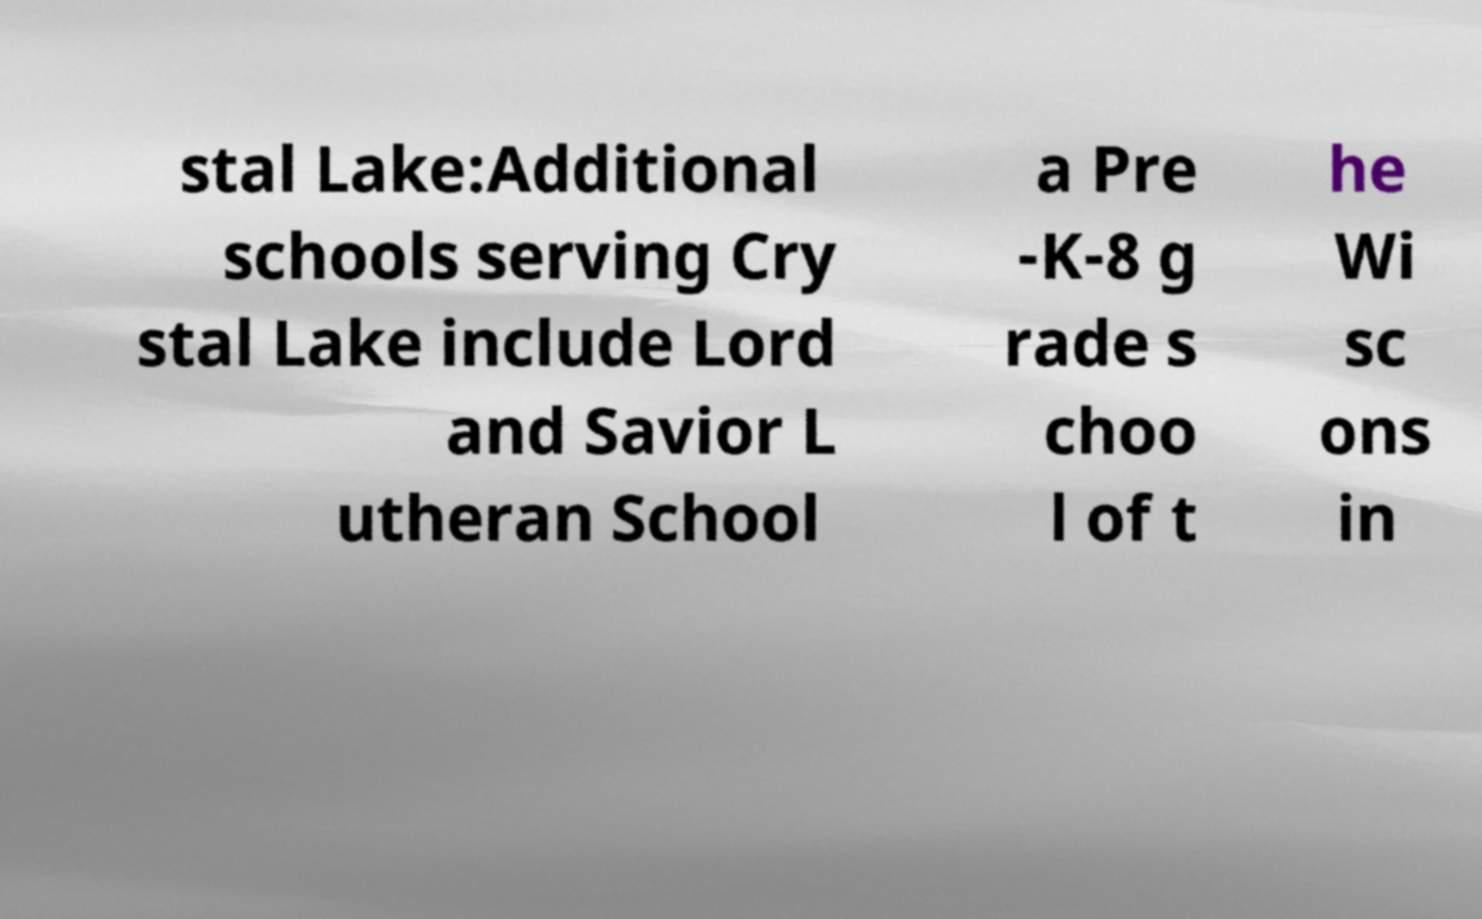I need the written content from this picture converted into text. Can you do that? stal Lake:Additional schools serving Cry stal Lake include Lord and Savior L utheran School a Pre -K-8 g rade s choo l of t he Wi sc ons in 